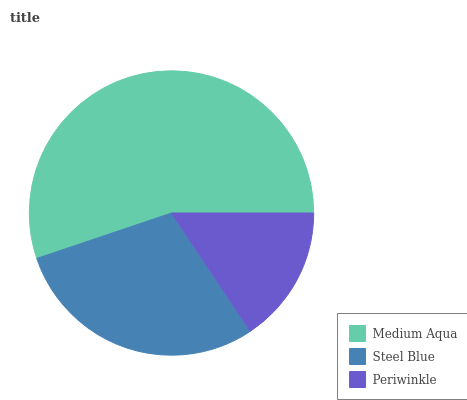Is Periwinkle the minimum?
Answer yes or no. Yes. Is Medium Aqua the maximum?
Answer yes or no. Yes. Is Steel Blue the minimum?
Answer yes or no. No. Is Steel Blue the maximum?
Answer yes or no. No. Is Medium Aqua greater than Steel Blue?
Answer yes or no. Yes. Is Steel Blue less than Medium Aqua?
Answer yes or no. Yes. Is Steel Blue greater than Medium Aqua?
Answer yes or no. No. Is Medium Aqua less than Steel Blue?
Answer yes or no. No. Is Steel Blue the high median?
Answer yes or no. Yes. Is Steel Blue the low median?
Answer yes or no. Yes. Is Medium Aqua the high median?
Answer yes or no. No. Is Medium Aqua the low median?
Answer yes or no. No. 